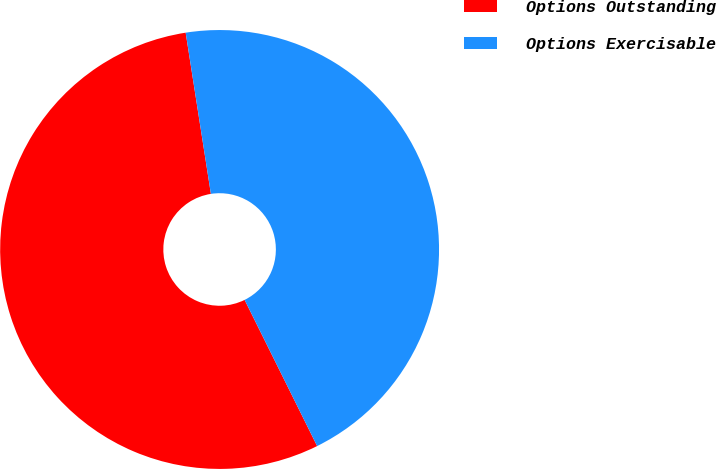<chart> <loc_0><loc_0><loc_500><loc_500><pie_chart><fcel>Options Outstanding<fcel>Options Exercisable<nl><fcel>54.86%<fcel>45.14%<nl></chart> 